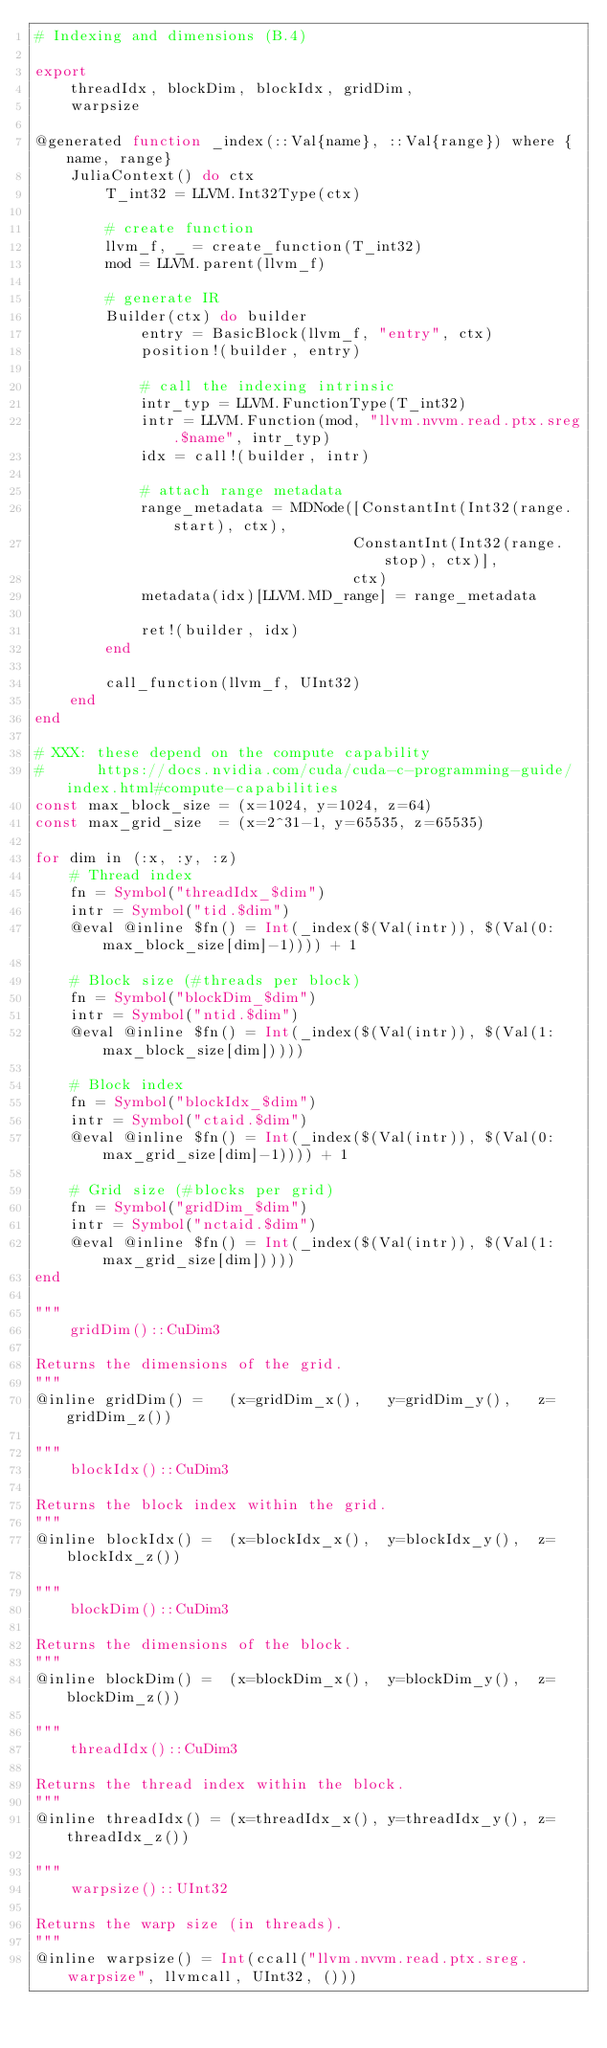Convert code to text. <code><loc_0><loc_0><loc_500><loc_500><_Julia_># Indexing and dimensions (B.4)

export
    threadIdx, blockDim, blockIdx, gridDim,
    warpsize

@generated function _index(::Val{name}, ::Val{range}) where {name, range}
    JuliaContext() do ctx
        T_int32 = LLVM.Int32Type(ctx)

        # create function
        llvm_f, _ = create_function(T_int32)
        mod = LLVM.parent(llvm_f)

        # generate IR
        Builder(ctx) do builder
            entry = BasicBlock(llvm_f, "entry", ctx)
            position!(builder, entry)

            # call the indexing intrinsic
            intr_typ = LLVM.FunctionType(T_int32)
            intr = LLVM.Function(mod, "llvm.nvvm.read.ptx.sreg.$name", intr_typ)
            idx = call!(builder, intr)

            # attach range metadata
            range_metadata = MDNode([ConstantInt(Int32(range.start), ctx),
                                    ConstantInt(Int32(range.stop), ctx)],
                                    ctx)
            metadata(idx)[LLVM.MD_range] = range_metadata

            ret!(builder, idx)
        end

        call_function(llvm_f, UInt32)
    end
end

# XXX: these depend on the compute capability
#      https://docs.nvidia.com/cuda/cuda-c-programming-guide/index.html#compute-capabilities
const max_block_size = (x=1024, y=1024, z=64)
const max_grid_size  = (x=2^31-1, y=65535, z=65535)

for dim in (:x, :y, :z)
    # Thread index
    fn = Symbol("threadIdx_$dim")
    intr = Symbol("tid.$dim")
    @eval @inline $fn() = Int(_index($(Val(intr)), $(Val(0:max_block_size[dim]-1)))) + 1

    # Block size (#threads per block)
    fn = Symbol("blockDim_$dim")
    intr = Symbol("ntid.$dim")
    @eval @inline $fn() = Int(_index($(Val(intr)), $(Val(1:max_block_size[dim]))))

    # Block index
    fn = Symbol("blockIdx_$dim")
    intr = Symbol("ctaid.$dim")
    @eval @inline $fn() = Int(_index($(Val(intr)), $(Val(0:max_grid_size[dim]-1)))) + 1

    # Grid size (#blocks per grid)
    fn = Symbol("gridDim_$dim")
    intr = Symbol("nctaid.$dim")
    @eval @inline $fn() = Int(_index($(Val(intr)), $(Val(1:max_grid_size[dim]))))
end

"""
    gridDim()::CuDim3

Returns the dimensions of the grid.
"""
@inline gridDim() =   (x=gridDim_x(),   y=gridDim_y(),   z=gridDim_z())

"""
    blockIdx()::CuDim3

Returns the block index within the grid.
"""
@inline blockIdx() =  (x=blockIdx_x(),  y=blockIdx_y(),  z=blockIdx_z())

"""
    blockDim()::CuDim3

Returns the dimensions of the block.
"""
@inline blockDim() =  (x=blockDim_x(),  y=blockDim_y(),  z=blockDim_z())

"""
    threadIdx()::CuDim3

Returns the thread index within the block.
"""
@inline threadIdx() = (x=threadIdx_x(), y=threadIdx_y(), z=threadIdx_z())

"""
    warpsize()::UInt32

Returns the warp size (in threads).
"""
@inline warpsize() = Int(ccall("llvm.nvvm.read.ptx.sreg.warpsize", llvmcall, UInt32, ()))
</code> 